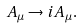Convert formula to latex. <formula><loc_0><loc_0><loc_500><loc_500>A _ { \mu } \rightarrow i A _ { \mu } .</formula> 